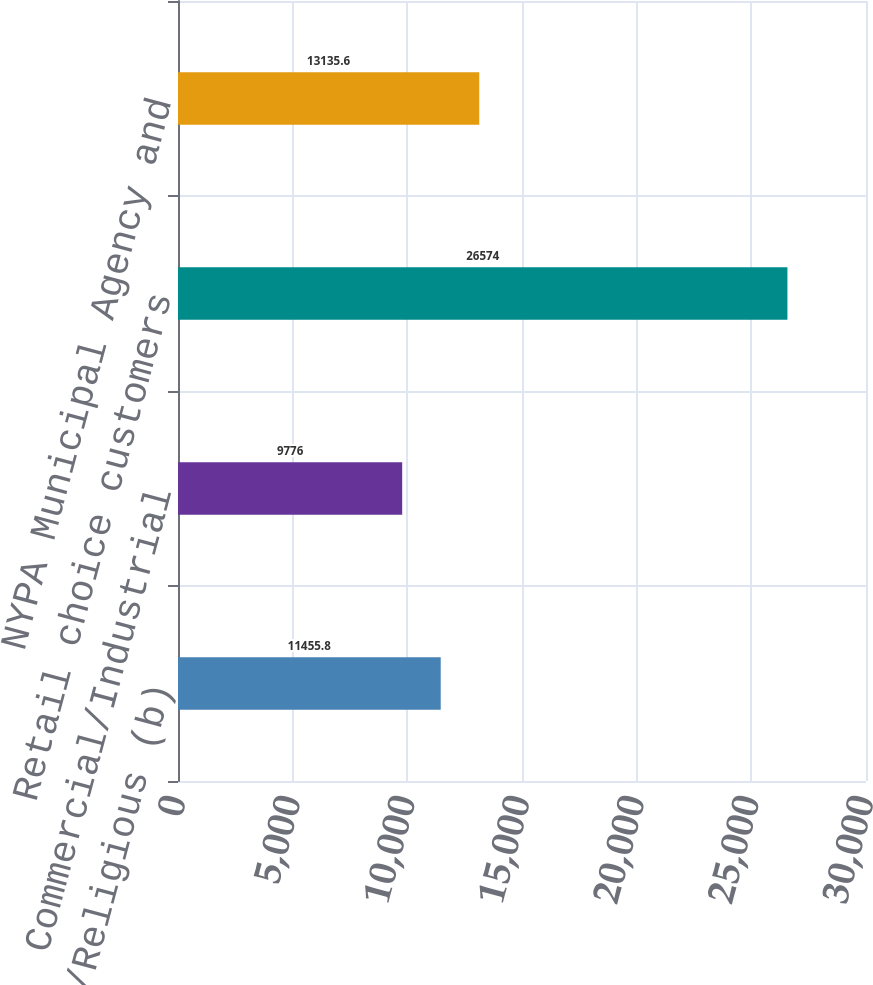Convert chart. <chart><loc_0><loc_0><loc_500><loc_500><bar_chart><fcel>Residential/Religious (b)<fcel>Commercial/Industrial<fcel>Retail choice customers<fcel>NYPA Municipal Agency and<nl><fcel>11455.8<fcel>9776<fcel>26574<fcel>13135.6<nl></chart> 